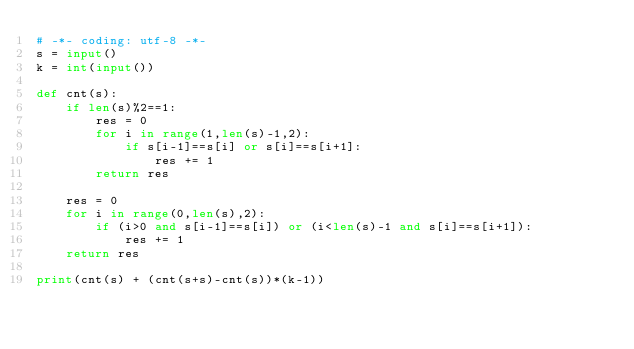Convert code to text. <code><loc_0><loc_0><loc_500><loc_500><_Python_># -*- coding: utf-8 -*-
s = input()
k = int(input())

def cnt(s):
    if len(s)%2==1:
        res = 0
        for i in range(1,len(s)-1,2):
            if s[i-1]==s[i] or s[i]==s[i+1]:
                res += 1
        return res
    
    res = 0
    for i in range(0,len(s),2):
        if (i>0 and s[i-1]==s[i]) or (i<len(s)-1 and s[i]==s[i+1]):
            res += 1
    return res

print(cnt(s) + (cnt(s+s)-cnt(s))*(k-1))</code> 